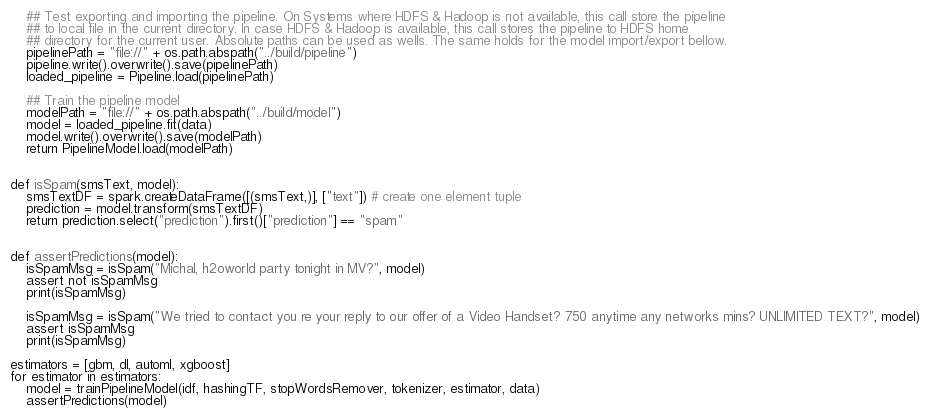Convert code to text. <code><loc_0><loc_0><loc_500><loc_500><_Python_>    ## Test exporting and importing the pipeline. On Systems where HDFS & Hadoop is not available, this call store the pipeline
    ## to local file in the current directory. In case HDFS & Hadoop is available, this call stores the pipeline to HDFS home
    ## directory for the current user. Absolute paths can be used as wells. The same holds for the model import/export bellow.
    pipelinePath = "file://" + os.path.abspath("../build/pipeline")
    pipeline.write().overwrite().save(pipelinePath)
    loaded_pipeline = Pipeline.load(pipelinePath)

    ## Train the pipeline model
    modelPath = "file://" + os.path.abspath("../build/model")
    model = loaded_pipeline.fit(data)
    model.write().overwrite().save(modelPath)
    return PipelineModel.load(modelPath)


def isSpam(smsText, model):
    smsTextDF = spark.createDataFrame([(smsText,)], ["text"]) # create one element tuple
    prediction = model.transform(smsTextDF)
    return prediction.select("prediction").first()["prediction"] == "spam"


def assertPredictions(model):
    isSpamMsg = isSpam("Michal, h2oworld party tonight in MV?", model)
    assert not isSpamMsg
    print(isSpamMsg)

    isSpamMsg = isSpam("We tried to contact you re your reply to our offer of a Video Handset? 750 anytime any networks mins? UNLIMITED TEXT?", model)
    assert isSpamMsg
    print(isSpamMsg)

estimators = [gbm, dl, automl, xgboost]
for estimator in estimators:
    model = trainPipelineModel(idf, hashingTF, stopWordsRemover, tokenizer, estimator, data)
    assertPredictions(model)
</code> 